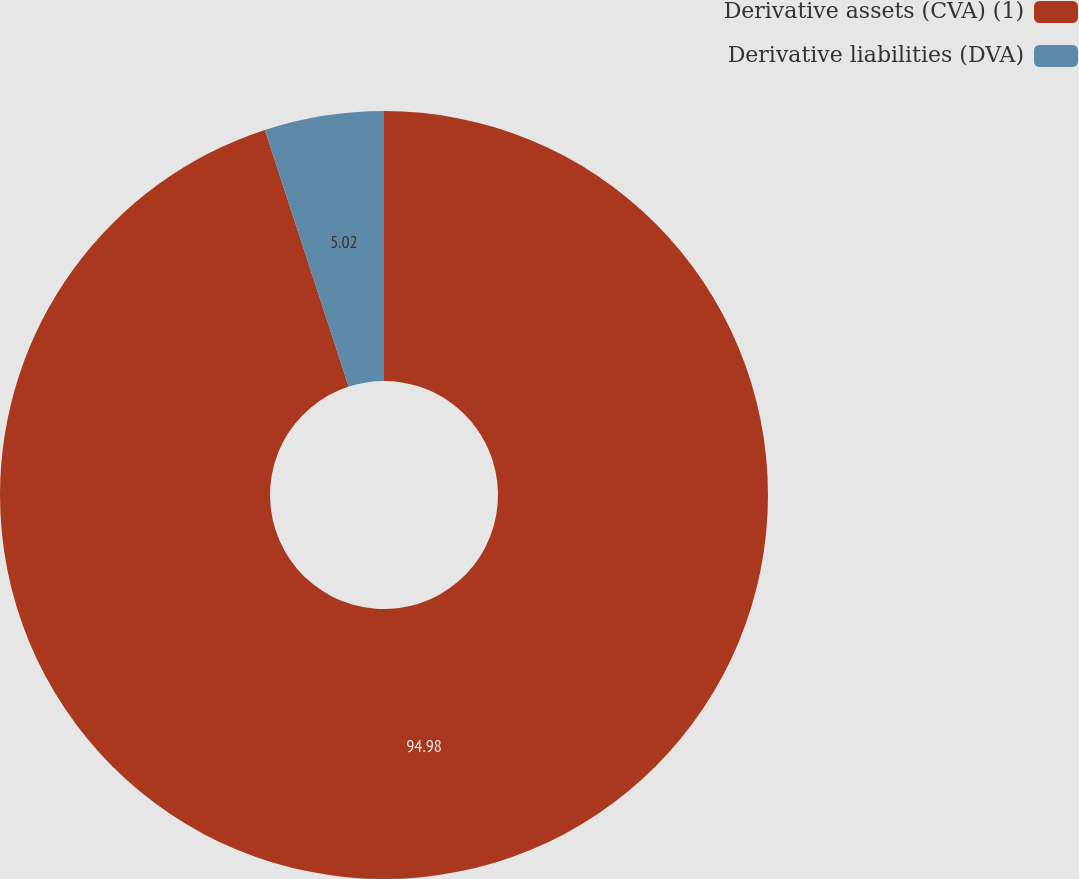Convert chart to OTSL. <chart><loc_0><loc_0><loc_500><loc_500><pie_chart><fcel>Derivative assets (CVA) (1)<fcel>Derivative liabilities (DVA)<nl><fcel>94.98%<fcel>5.02%<nl></chart> 